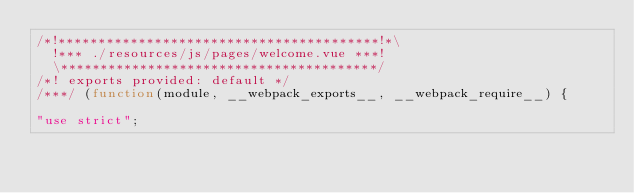<code> <loc_0><loc_0><loc_500><loc_500><_JavaScript_>/*!****************************************!*\
  !*** ./resources/js/pages/welcome.vue ***!
  \****************************************/
/*! exports provided: default */
/***/ (function(module, __webpack_exports__, __webpack_require__) {

"use strict";</code> 